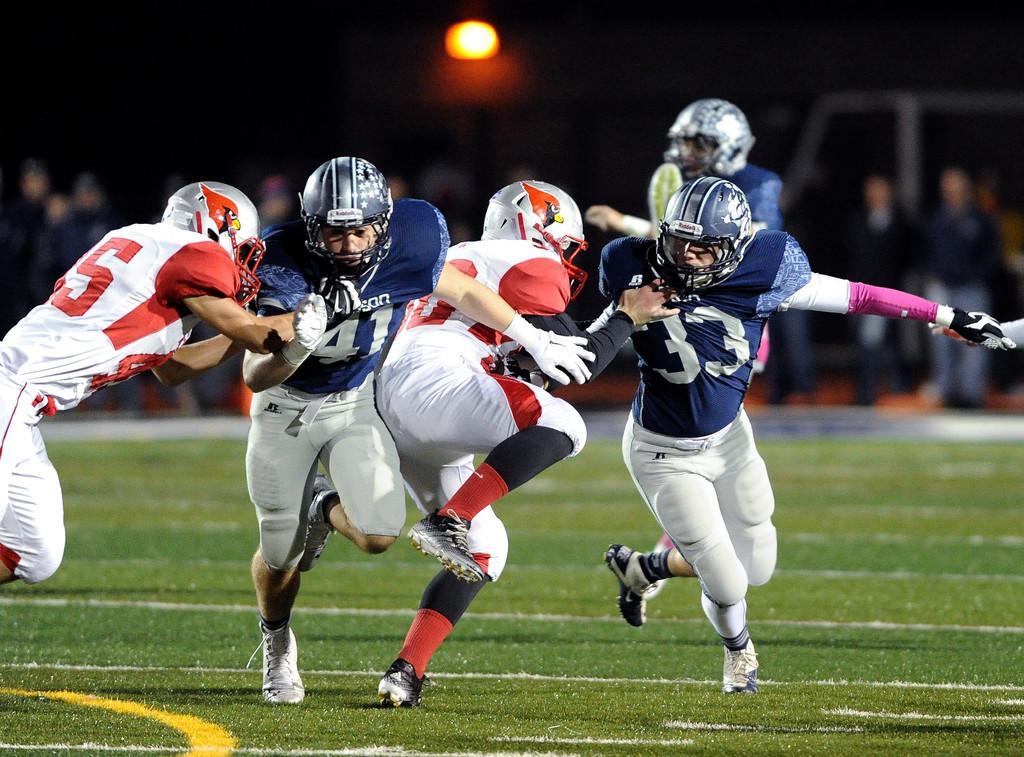How would you summarize this image in a sentence or two? In this image there are persons playing and the background is blurry and there is grass on the ground. 